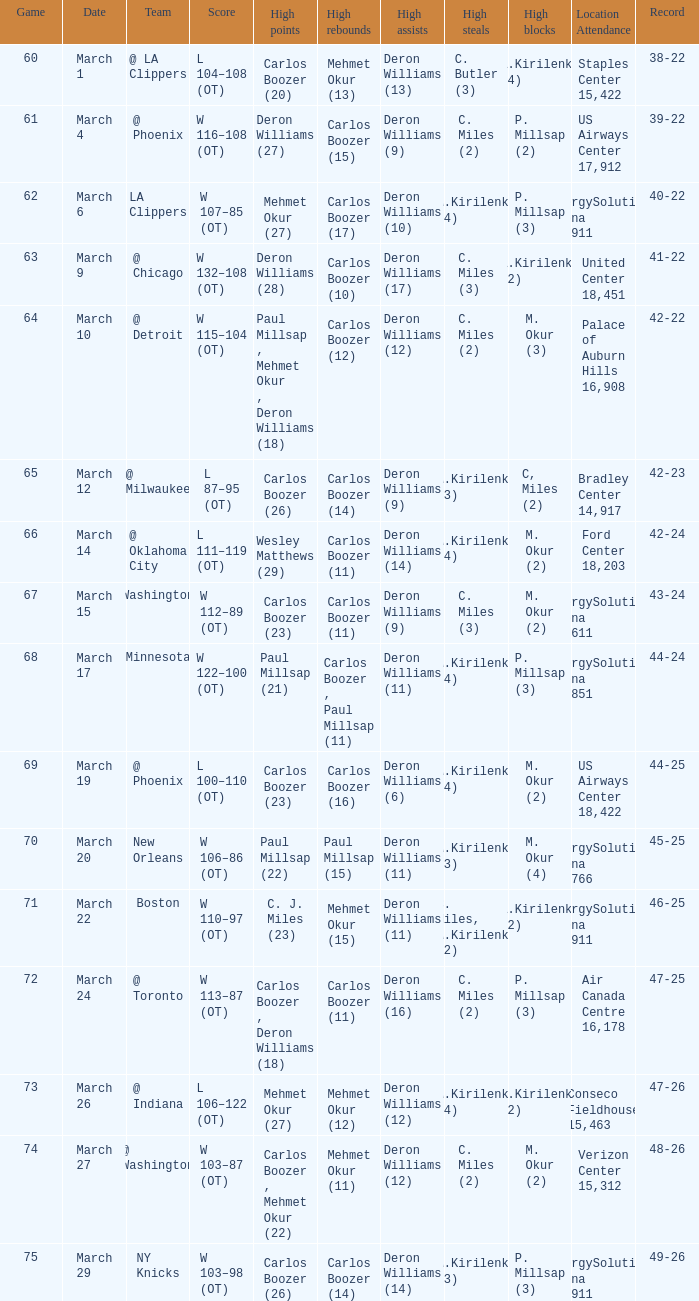How many players did the most high points in the game with 39-22 record? 1.0. 